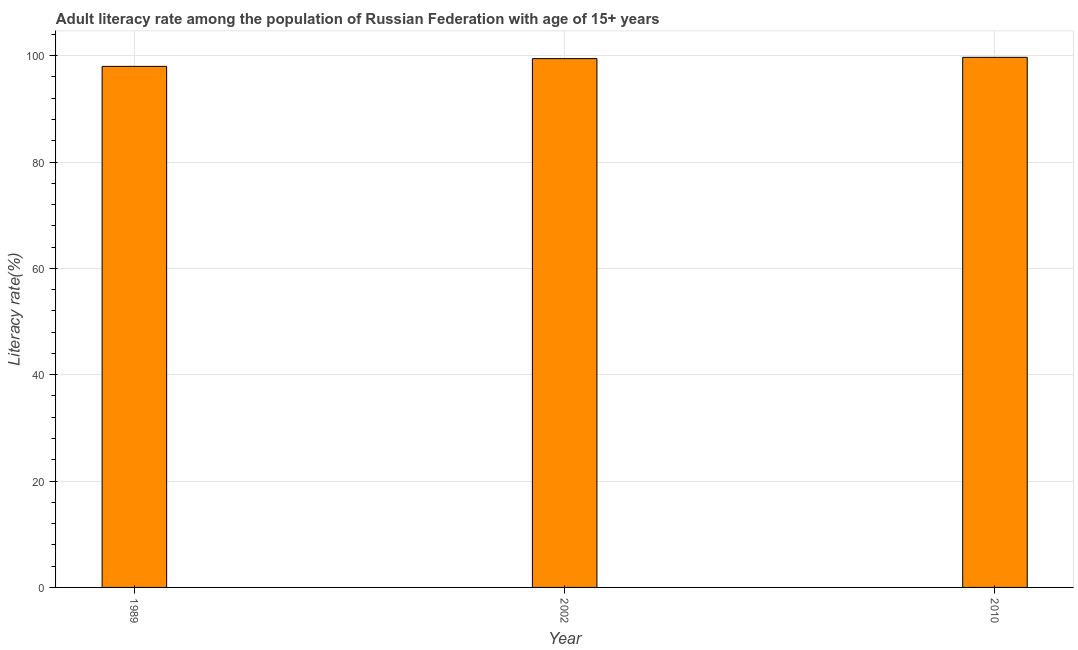Does the graph contain grids?
Offer a very short reply. Yes. What is the title of the graph?
Offer a terse response. Adult literacy rate among the population of Russian Federation with age of 15+ years. What is the label or title of the Y-axis?
Keep it short and to the point. Literacy rate(%). What is the adult literacy rate in 1989?
Offer a terse response. 97.99. Across all years, what is the maximum adult literacy rate?
Provide a succinct answer. 99.68. Across all years, what is the minimum adult literacy rate?
Offer a very short reply. 97.99. In which year was the adult literacy rate maximum?
Give a very brief answer. 2010. What is the sum of the adult literacy rate?
Offer a very short reply. 297.11. What is the difference between the adult literacy rate in 1989 and 2010?
Your answer should be compact. -1.7. What is the average adult literacy rate per year?
Your answer should be very brief. 99.04. What is the median adult literacy rate?
Give a very brief answer. 99.44. In how many years, is the adult literacy rate greater than 4 %?
Provide a short and direct response. 3. What is the ratio of the adult literacy rate in 2002 to that in 2010?
Ensure brevity in your answer.  1. Is the adult literacy rate in 1989 less than that in 2002?
Your answer should be very brief. Yes. Is the difference between the adult literacy rate in 1989 and 2010 greater than the difference between any two years?
Make the answer very short. Yes. What is the difference between the highest and the second highest adult literacy rate?
Make the answer very short. 0.24. In how many years, is the adult literacy rate greater than the average adult literacy rate taken over all years?
Offer a very short reply. 2. How many bars are there?
Your response must be concise. 3. How many years are there in the graph?
Provide a succinct answer. 3. What is the difference between two consecutive major ticks on the Y-axis?
Give a very brief answer. 20. Are the values on the major ticks of Y-axis written in scientific E-notation?
Provide a short and direct response. No. What is the Literacy rate(%) in 1989?
Make the answer very short. 97.99. What is the Literacy rate(%) in 2002?
Offer a terse response. 99.44. What is the Literacy rate(%) of 2010?
Make the answer very short. 99.68. What is the difference between the Literacy rate(%) in 1989 and 2002?
Offer a terse response. -1.45. What is the difference between the Literacy rate(%) in 1989 and 2010?
Offer a very short reply. -1.7. What is the difference between the Literacy rate(%) in 2002 and 2010?
Your response must be concise. -0.24. What is the ratio of the Literacy rate(%) in 1989 to that in 2002?
Make the answer very short. 0.98. What is the ratio of the Literacy rate(%) in 1989 to that in 2010?
Make the answer very short. 0.98. What is the ratio of the Literacy rate(%) in 2002 to that in 2010?
Your answer should be very brief. 1. 